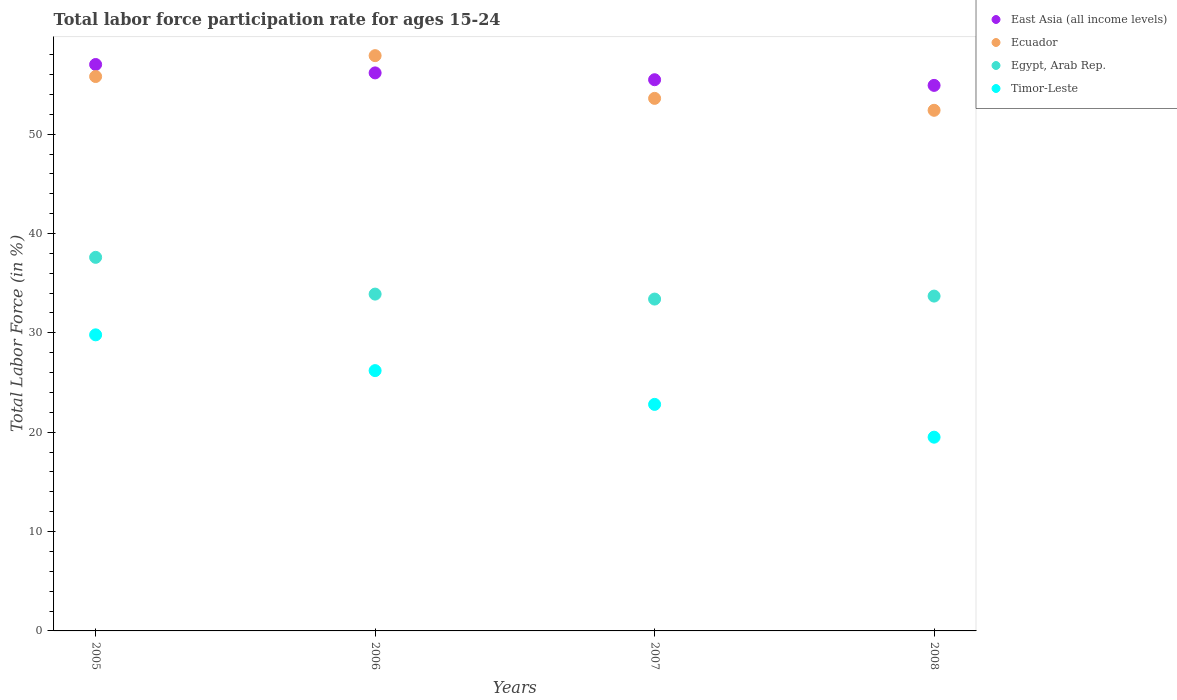Is the number of dotlines equal to the number of legend labels?
Offer a very short reply. Yes. What is the labor force participation rate in Timor-Leste in 2006?
Provide a short and direct response. 26.2. Across all years, what is the maximum labor force participation rate in Ecuador?
Provide a succinct answer. 57.9. Across all years, what is the minimum labor force participation rate in Ecuador?
Offer a terse response. 52.4. In which year was the labor force participation rate in Ecuador maximum?
Provide a short and direct response. 2006. In which year was the labor force participation rate in East Asia (all income levels) minimum?
Your answer should be compact. 2008. What is the total labor force participation rate in Timor-Leste in the graph?
Offer a terse response. 98.3. What is the difference between the labor force participation rate in Timor-Leste in 2006 and that in 2008?
Provide a short and direct response. 6.7. What is the difference between the labor force participation rate in Egypt, Arab Rep. in 2006 and the labor force participation rate in Timor-Leste in 2007?
Provide a succinct answer. 11.1. What is the average labor force participation rate in Ecuador per year?
Your answer should be compact. 54.93. In the year 2006, what is the difference between the labor force participation rate in Ecuador and labor force participation rate in Timor-Leste?
Offer a very short reply. 31.7. In how many years, is the labor force participation rate in Timor-Leste greater than 56 %?
Offer a terse response. 0. What is the ratio of the labor force participation rate in Ecuador in 2005 to that in 2008?
Your answer should be very brief. 1.06. Is the labor force participation rate in East Asia (all income levels) in 2005 less than that in 2008?
Make the answer very short. No. What is the difference between the highest and the second highest labor force participation rate in Timor-Leste?
Your answer should be compact. 3.6. What is the difference between the highest and the lowest labor force participation rate in East Asia (all income levels)?
Offer a very short reply. 2.1. Is the sum of the labor force participation rate in East Asia (all income levels) in 2005 and 2007 greater than the maximum labor force participation rate in Timor-Leste across all years?
Provide a short and direct response. Yes. Is the labor force participation rate in East Asia (all income levels) strictly greater than the labor force participation rate in Ecuador over the years?
Your answer should be compact. No. How many dotlines are there?
Keep it short and to the point. 4. What is the difference between two consecutive major ticks on the Y-axis?
Keep it short and to the point. 10. Does the graph contain any zero values?
Provide a succinct answer. No. Does the graph contain grids?
Provide a short and direct response. No. Where does the legend appear in the graph?
Provide a short and direct response. Top right. How many legend labels are there?
Keep it short and to the point. 4. What is the title of the graph?
Make the answer very short. Total labor force participation rate for ages 15-24. What is the Total Labor Force (in %) of East Asia (all income levels) in 2005?
Give a very brief answer. 57.01. What is the Total Labor Force (in %) of Ecuador in 2005?
Your answer should be compact. 55.8. What is the Total Labor Force (in %) in Egypt, Arab Rep. in 2005?
Ensure brevity in your answer.  37.6. What is the Total Labor Force (in %) in Timor-Leste in 2005?
Give a very brief answer. 29.8. What is the Total Labor Force (in %) of East Asia (all income levels) in 2006?
Your answer should be compact. 56.16. What is the Total Labor Force (in %) in Ecuador in 2006?
Provide a short and direct response. 57.9. What is the Total Labor Force (in %) of Egypt, Arab Rep. in 2006?
Give a very brief answer. 33.9. What is the Total Labor Force (in %) in Timor-Leste in 2006?
Offer a very short reply. 26.2. What is the Total Labor Force (in %) in East Asia (all income levels) in 2007?
Provide a succinct answer. 55.48. What is the Total Labor Force (in %) of Ecuador in 2007?
Make the answer very short. 53.6. What is the Total Labor Force (in %) in Egypt, Arab Rep. in 2007?
Your answer should be very brief. 33.4. What is the Total Labor Force (in %) of Timor-Leste in 2007?
Offer a terse response. 22.8. What is the Total Labor Force (in %) in East Asia (all income levels) in 2008?
Offer a terse response. 54.91. What is the Total Labor Force (in %) in Ecuador in 2008?
Your answer should be very brief. 52.4. What is the Total Labor Force (in %) in Egypt, Arab Rep. in 2008?
Keep it short and to the point. 33.7. What is the Total Labor Force (in %) of Timor-Leste in 2008?
Provide a short and direct response. 19.5. Across all years, what is the maximum Total Labor Force (in %) of East Asia (all income levels)?
Your response must be concise. 57.01. Across all years, what is the maximum Total Labor Force (in %) of Ecuador?
Give a very brief answer. 57.9. Across all years, what is the maximum Total Labor Force (in %) of Egypt, Arab Rep.?
Make the answer very short. 37.6. Across all years, what is the maximum Total Labor Force (in %) of Timor-Leste?
Provide a short and direct response. 29.8. Across all years, what is the minimum Total Labor Force (in %) in East Asia (all income levels)?
Your answer should be very brief. 54.91. Across all years, what is the minimum Total Labor Force (in %) of Ecuador?
Offer a terse response. 52.4. Across all years, what is the minimum Total Labor Force (in %) in Egypt, Arab Rep.?
Keep it short and to the point. 33.4. What is the total Total Labor Force (in %) of East Asia (all income levels) in the graph?
Provide a succinct answer. 223.56. What is the total Total Labor Force (in %) of Ecuador in the graph?
Your response must be concise. 219.7. What is the total Total Labor Force (in %) in Egypt, Arab Rep. in the graph?
Keep it short and to the point. 138.6. What is the total Total Labor Force (in %) in Timor-Leste in the graph?
Provide a succinct answer. 98.3. What is the difference between the Total Labor Force (in %) of East Asia (all income levels) in 2005 and that in 2006?
Ensure brevity in your answer.  0.84. What is the difference between the Total Labor Force (in %) of Timor-Leste in 2005 and that in 2006?
Keep it short and to the point. 3.6. What is the difference between the Total Labor Force (in %) of East Asia (all income levels) in 2005 and that in 2007?
Ensure brevity in your answer.  1.53. What is the difference between the Total Labor Force (in %) of Timor-Leste in 2005 and that in 2007?
Ensure brevity in your answer.  7. What is the difference between the Total Labor Force (in %) of East Asia (all income levels) in 2005 and that in 2008?
Keep it short and to the point. 2.1. What is the difference between the Total Labor Force (in %) of Ecuador in 2005 and that in 2008?
Provide a short and direct response. 3.4. What is the difference between the Total Labor Force (in %) of Timor-Leste in 2005 and that in 2008?
Your response must be concise. 10.3. What is the difference between the Total Labor Force (in %) in East Asia (all income levels) in 2006 and that in 2007?
Make the answer very short. 0.69. What is the difference between the Total Labor Force (in %) of Egypt, Arab Rep. in 2006 and that in 2007?
Your answer should be very brief. 0.5. What is the difference between the Total Labor Force (in %) in East Asia (all income levels) in 2006 and that in 2008?
Offer a very short reply. 1.26. What is the difference between the Total Labor Force (in %) of Ecuador in 2006 and that in 2008?
Your answer should be very brief. 5.5. What is the difference between the Total Labor Force (in %) in Egypt, Arab Rep. in 2006 and that in 2008?
Offer a very short reply. 0.2. What is the difference between the Total Labor Force (in %) in East Asia (all income levels) in 2007 and that in 2008?
Your response must be concise. 0.57. What is the difference between the Total Labor Force (in %) in Ecuador in 2007 and that in 2008?
Offer a very short reply. 1.2. What is the difference between the Total Labor Force (in %) of Timor-Leste in 2007 and that in 2008?
Provide a succinct answer. 3.3. What is the difference between the Total Labor Force (in %) in East Asia (all income levels) in 2005 and the Total Labor Force (in %) in Ecuador in 2006?
Offer a very short reply. -0.89. What is the difference between the Total Labor Force (in %) in East Asia (all income levels) in 2005 and the Total Labor Force (in %) in Egypt, Arab Rep. in 2006?
Your response must be concise. 23.11. What is the difference between the Total Labor Force (in %) in East Asia (all income levels) in 2005 and the Total Labor Force (in %) in Timor-Leste in 2006?
Offer a terse response. 30.81. What is the difference between the Total Labor Force (in %) of Ecuador in 2005 and the Total Labor Force (in %) of Egypt, Arab Rep. in 2006?
Your answer should be compact. 21.9. What is the difference between the Total Labor Force (in %) in Ecuador in 2005 and the Total Labor Force (in %) in Timor-Leste in 2006?
Offer a terse response. 29.6. What is the difference between the Total Labor Force (in %) in East Asia (all income levels) in 2005 and the Total Labor Force (in %) in Ecuador in 2007?
Offer a very short reply. 3.41. What is the difference between the Total Labor Force (in %) of East Asia (all income levels) in 2005 and the Total Labor Force (in %) of Egypt, Arab Rep. in 2007?
Ensure brevity in your answer.  23.61. What is the difference between the Total Labor Force (in %) in East Asia (all income levels) in 2005 and the Total Labor Force (in %) in Timor-Leste in 2007?
Provide a short and direct response. 34.21. What is the difference between the Total Labor Force (in %) in Ecuador in 2005 and the Total Labor Force (in %) in Egypt, Arab Rep. in 2007?
Keep it short and to the point. 22.4. What is the difference between the Total Labor Force (in %) of Egypt, Arab Rep. in 2005 and the Total Labor Force (in %) of Timor-Leste in 2007?
Give a very brief answer. 14.8. What is the difference between the Total Labor Force (in %) of East Asia (all income levels) in 2005 and the Total Labor Force (in %) of Ecuador in 2008?
Give a very brief answer. 4.61. What is the difference between the Total Labor Force (in %) in East Asia (all income levels) in 2005 and the Total Labor Force (in %) in Egypt, Arab Rep. in 2008?
Your answer should be very brief. 23.31. What is the difference between the Total Labor Force (in %) of East Asia (all income levels) in 2005 and the Total Labor Force (in %) of Timor-Leste in 2008?
Ensure brevity in your answer.  37.51. What is the difference between the Total Labor Force (in %) in Ecuador in 2005 and the Total Labor Force (in %) in Egypt, Arab Rep. in 2008?
Offer a very short reply. 22.1. What is the difference between the Total Labor Force (in %) of Ecuador in 2005 and the Total Labor Force (in %) of Timor-Leste in 2008?
Your answer should be compact. 36.3. What is the difference between the Total Labor Force (in %) in East Asia (all income levels) in 2006 and the Total Labor Force (in %) in Ecuador in 2007?
Your answer should be compact. 2.56. What is the difference between the Total Labor Force (in %) in East Asia (all income levels) in 2006 and the Total Labor Force (in %) in Egypt, Arab Rep. in 2007?
Your response must be concise. 22.76. What is the difference between the Total Labor Force (in %) of East Asia (all income levels) in 2006 and the Total Labor Force (in %) of Timor-Leste in 2007?
Give a very brief answer. 33.36. What is the difference between the Total Labor Force (in %) in Ecuador in 2006 and the Total Labor Force (in %) in Timor-Leste in 2007?
Make the answer very short. 35.1. What is the difference between the Total Labor Force (in %) of East Asia (all income levels) in 2006 and the Total Labor Force (in %) of Ecuador in 2008?
Offer a terse response. 3.76. What is the difference between the Total Labor Force (in %) in East Asia (all income levels) in 2006 and the Total Labor Force (in %) in Egypt, Arab Rep. in 2008?
Keep it short and to the point. 22.46. What is the difference between the Total Labor Force (in %) in East Asia (all income levels) in 2006 and the Total Labor Force (in %) in Timor-Leste in 2008?
Offer a terse response. 36.66. What is the difference between the Total Labor Force (in %) in Ecuador in 2006 and the Total Labor Force (in %) in Egypt, Arab Rep. in 2008?
Offer a very short reply. 24.2. What is the difference between the Total Labor Force (in %) of Ecuador in 2006 and the Total Labor Force (in %) of Timor-Leste in 2008?
Provide a succinct answer. 38.4. What is the difference between the Total Labor Force (in %) of Egypt, Arab Rep. in 2006 and the Total Labor Force (in %) of Timor-Leste in 2008?
Your answer should be very brief. 14.4. What is the difference between the Total Labor Force (in %) of East Asia (all income levels) in 2007 and the Total Labor Force (in %) of Ecuador in 2008?
Your answer should be very brief. 3.08. What is the difference between the Total Labor Force (in %) in East Asia (all income levels) in 2007 and the Total Labor Force (in %) in Egypt, Arab Rep. in 2008?
Ensure brevity in your answer.  21.78. What is the difference between the Total Labor Force (in %) in East Asia (all income levels) in 2007 and the Total Labor Force (in %) in Timor-Leste in 2008?
Keep it short and to the point. 35.98. What is the difference between the Total Labor Force (in %) in Ecuador in 2007 and the Total Labor Force (in %) in Timor-Leste in 2008?
Your response must be concise. 34.1. What is the difference between the Total Labor Force (in %) of Egypt, Arab Rep. in 2007 and the Total Labor Force (in %) of Timor-Leste in 2008?
Your response must be concise. 13.9. What is the average Total Labor Force (in %) in East Asia (all income levels) per year?
Ensure brevity in your answer.  55.89. What is the average Total Labor Force (in %) in Ecuador per year?
Provide a short and direct response. 54.92. What is the average Total Labor Force (in %) of Egypt, Arab Rep. per year?
Make the answer very short. 34.65. What is the average Total Labor Force (in %) of Timor-Leste per year?
Provide a short and direct response. 24.57. In the year 2005, what is the difference between the Total Labor Force (in %) in East Asia (all income levels) and Total Labor Force (in %) in Ecuador?
Your response must be concise. 1.21. In the year 2005, what is the difference between the Total Labor Force (in %) of East Asia (all income levels) and Total Labor Force (in %) of Egypt, Arab Rep.?
Offer a very short reply. 19.41. In the year 2005, what is the difference between the Total Labor Force (in %) of East Asia (all income levels) and Total Labor Force (in %) of Timor-Leste?
Provide a short and direct response. 27.21. In the year 2005, what is the difference between the Total Labor Force (in %) of Egypt, Arab Rep. and Total Labor Force (in %) of Timor-Leste?
Offer a very short reply. 7.8. In the year 2006, what is the difference between the Total Labor Force (in %) in East Asia (all income levels) and Total Labor Force (in %) in Ecuador?
Offer a terse response. -1.74. In the year 2006, what is the difference between the Total Labor Force (in %) in East Asia (all income levels) and Total Labor Force (in %) in Egypt, Arab Rep.?
Make the answer very short. 22.26. In the year 2006, what is the difference between the Total Labor Force (in %) of East Asia (all income levels) and Total Labor Force (in %) of Timor-Leste?
Ensure brevity in your answer.  29.96. In the year 2006, what is the difference between the Total Labor Force (in %) of Ecuador and Total Labor Force (in %) of Timor-Leste?
Give a very brief answer. 31.7. In the year 2006, what is the difference between the Total Labor Force (in %) of Egypt, Arab Rep. and Total Labor Force (in %) of Timor-Leste?
Your answer should be very brief. 7.7. In the year 2007, what is the difference between the Total Labor Force (in %) of East Asia (all income levels) and Total Labor Force (in %) of Ecuador?
Offer a terse response. 1.88. In the year 2007, what is the difference between the Total Labor Force (in %) in East Asia (all income levels) and Total Labor Force (in %) in Egypt, Arab Rep.?
Make the answer very short. 22.08. In the year 2007, what is the difference between the Total Labor Force (in %) of East Asia (all income levels) and Total Labor Force (in %) of Timor-Leste?
Your answer should be compact. 32.68. In the year 2007, what is the difference between the Total Labor Force (in %) of Ecuador and Total Labor Force (in %) of Egypt, Arab Rep.?
Your answer should be very brief. 20.2. In the year 2007, what is the difference between the Total Labor Force (in %) in Ecuador and Total Labor Force (in %) in Timor-Leste?
Provide a short and direct response. 30.8. In the year 2007, what is the difference between the Total Labor Force (in %) of Egypt, Arab Rep. and Total Labor Force (in %) of Timor-Leste?
Give a very brief answer. 10.6. In the year 2008, what is the difference between the Total Labor Force (in %) in East Asia (all income levels) and Total Labor Force (in %) in Ecuador?
Offer a terse response. 2.51. In the year 2008, what is the difference between the Total Labor Force (in %) in East Asia (all income levels) and Total Labor Force (in %) in Egypt, Arab Rep.?
Your answer should be compact. 21.21. In the year 2008, what is the difference between the Total Labor Force (in %) in East Asia (all income levels) and Total Labor Force (in %) in Timor-Leste?
Keep it short and to the point. 35.41. In the year 2008, what is the difference between the Total Labor Force (in %) in Ecuador and Total Labor Force (in %) in Timor-Leste?
Offer a terse response. 32.9. What is the ratio of the Total Labor Force (in %) of Ecuador in 2005 to that in 2006?
Ensure brevity in your answer.  0.96. What is the ratio of the Total Labor Force (in %) in Egypt, Arab Rep. in 2005 to that in 2006?
Offer a very short reply. 1.11. What is the ratio of the Total Labor Force (in %) in Timor-Leste in 2005 to that in 2006?
Give a very brief answer. 1.14. What is the ratio of the Total Labor Force (in %) of East Asia (all income levels) in 2005 to that in 2007?
Ensure brevity in your answer.  1.03. What is the ratio of the Total Labor Force (in %) in Ecuador in 2005 to that in 2007?
Make the answer very short. 1.04. What is the ratio of the Total Labor Force (in %) of Egypt, Arab Rep. in 2005 to that in 2007?
Your answer should be compact. 1.13. What is the ratio of the Total Labor Force (in %) in Timor-Leste in 2005 to that in 2007?
Keep it short and to the point. 1.31. What is the ratio of the Total Labor Force (in %) in East Asia (all income levels) in 2005 to that in 2008?
Provide a succinct answer. 1.04. What is the ratio of the Total Labor Force (in %) in Ecuador in 2005 to that in 2008?
Your answer should be compact. 1.06. What is the ratio of the Total Labor Force (in %) in Egypt, Arab Rep. in 2005 to that in 2008?
Offer a very short reply. 1.12. What is the ratio of the Total Labor Force (in %) of Timor-Leste in 2005 to that in 2008?
Ensure brevity in your answer.  1.53. What is the ratio of the Total Labor Force (in %) of East Asia (all income levels) in 2006 to that in 2007?
Make the answer very short. 1.01. What is the ratio of the Total Labor Force (in %) in Ecuador in 2006 to that in 2007?
Provide a short and direct response. 1.08. What is the ratio of the Total Labor Force (in %) of Egypt, Arab Rep. in 2006 to that in 2007?
Give a very brief answer. 1.01. What is the ratio of the Total Labor Force (in %) in Timor-Leste in 2006 to that in 2007?
Your answer should be very brief. 1.15. What is the ratio of the Total Labor Force (in %) of East Asia (all income levels) in 2006 to that in 2008?
Your answer should be compact. 1.02. What is the ratio of the Total Labor Force (in %) in Ecuador in 2006 to that in 2008?
Provide a succinct answer. 1.1. What is the ratio of the Total Labor Force (in %) of Egypt, Arab Rep. in 2006 to that in 2008?
Provide a succinct answer. 1.01. What is the ratio of the Total Labor Force (in %) of Timor-Leste in 2006 to that in 2008?
Your response must be concise. 1.34. What is the ratio of the Total Labor Force (in %) in East Asia (all income levels) in 2007 to that in 2008?
Your response must be concise. 1.01. What is the ratio of the Total Labor Force (in %) in Ecuador in 2007 to that in 2008?
Offer a terse response. 1.02. What is the ratio of the Total Labor Force (in %) in Egypt, Arab Rep. in 2007 to that in 2008?
Offer a very short reply. 0.99. What is the ratio of the Total Labor Force (in %) in Timor-Leste in 2007 to that in 2008?
Provide a short and direct response. 1.17. What is the difference between the highest and the second highest Total Labor Force (in %) in East Asia (all income levels)?
Give a very brief answer. 0.84. What is the difference between the highest and the second highest Total Labor Force (in %) of Egypt, Arab Rep.?
Provide a short and direct response. 3.7. What is the difference between the highest and the lowest Total Labor Force (in %) in East Asia (all income levels)?
Give a very brief answer. 2.1. What is the difference between the highest and the lowest Total Labor Force (in %) in Timor-Leste?
Offer a very short reply. 10.3. 